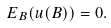Convert formula to latex. <formula><loc_0><loc_0><loc_500><loc_500>E _ { B } ( u ( B ) ) = 0 .</formula> 